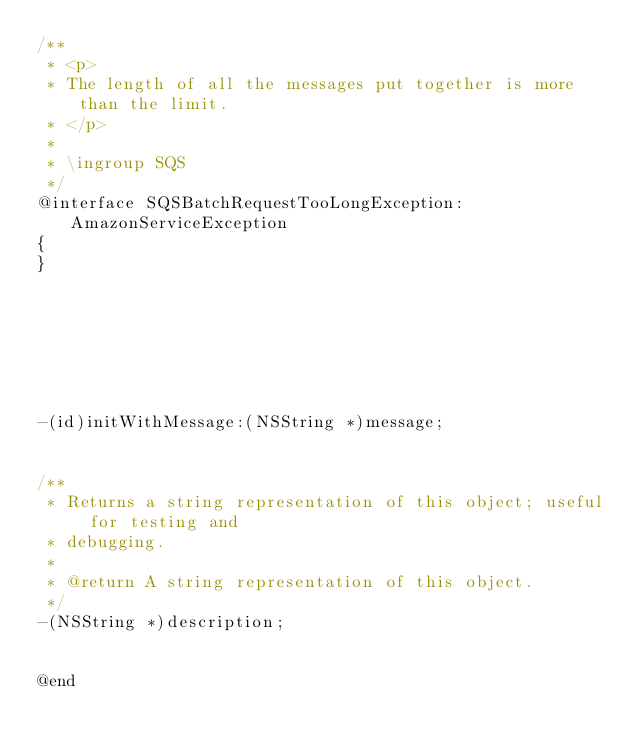<code> <loc_0><loc_0><loc_500><loc_500><_C_>/**
 * <p>
 * The length of all the messages put together is more than the limit.
 * </p>
 *
 * \ingroup SQS
 */
@interface SQSBatchRequestTooLongException:AmazonServiceException
{
}







-(id)initWithMessage:(NSString *)message;


/**
 * Returns a string representation of this object; useful for testing and
 * debugging.
 *
 * @return A string representation of this object.
 */
-(NSString *)description;


@end
</code> 